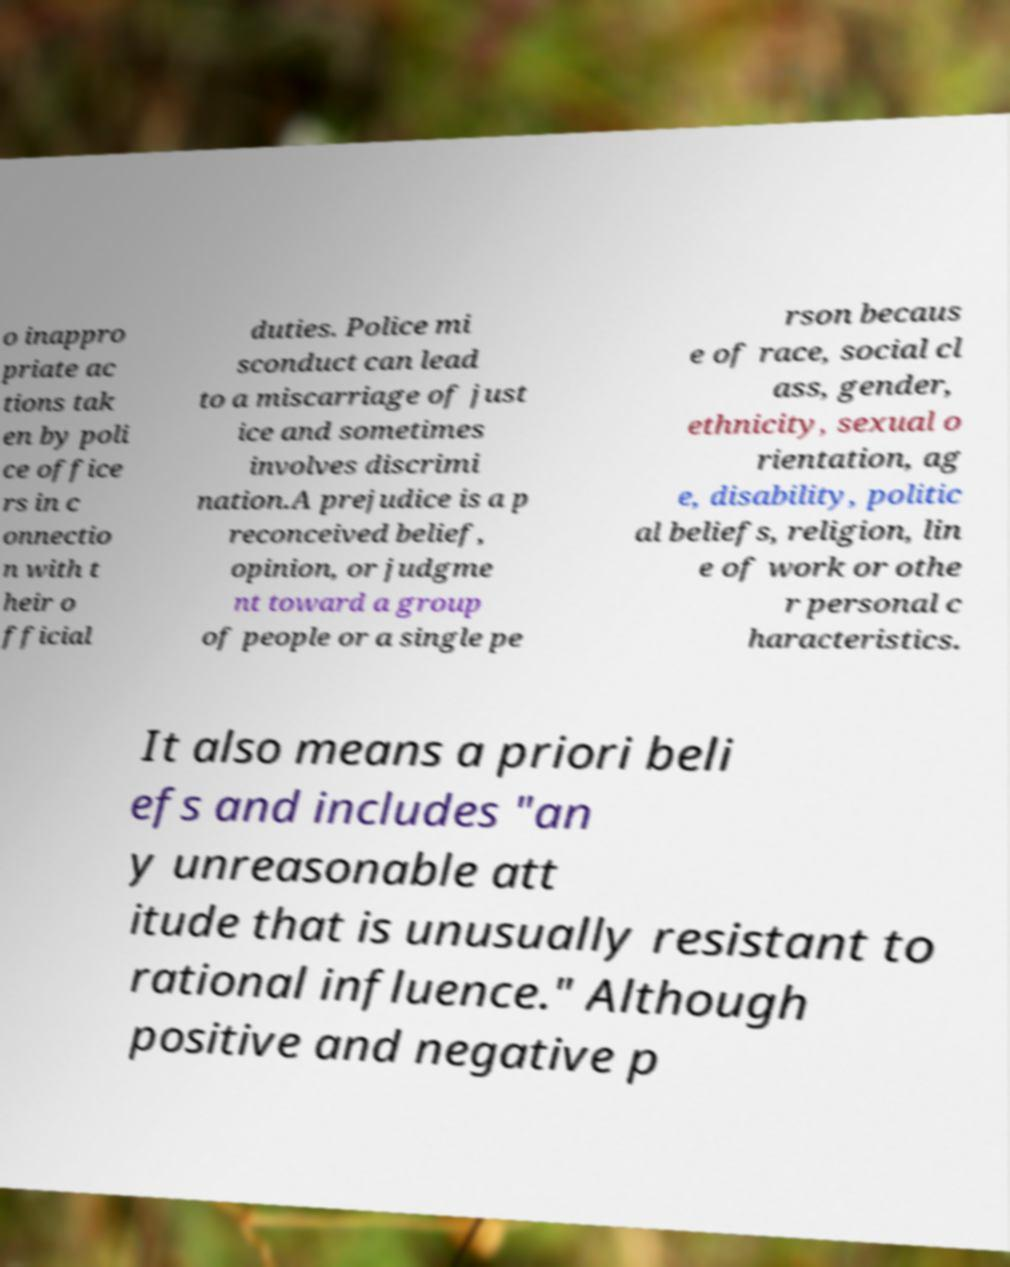There's text embedded in this image that I need extracted. Can you transcribe it verbatim? o inappro priate ac tions tak en by poli ce office rs in c onnectio n with t heir o fficial duties. Police mi sconduct can lead to a miscarriage of just ice and sometimes involves discrimi nation.A prejudice is a p reconceived belief, opinion, or judgme nt toward a group of people or a single pe rson becaus e of race, social cl ass, gender, ethnicity, sexual o rientation, ag e, disability, politic al beliefs, religion, lin e of work or othe r personal c haracteristics. It also means a priori beli efs and includes "an y unreasonable att itude that is unusually resistant to rational influence." Although positive and negative p 